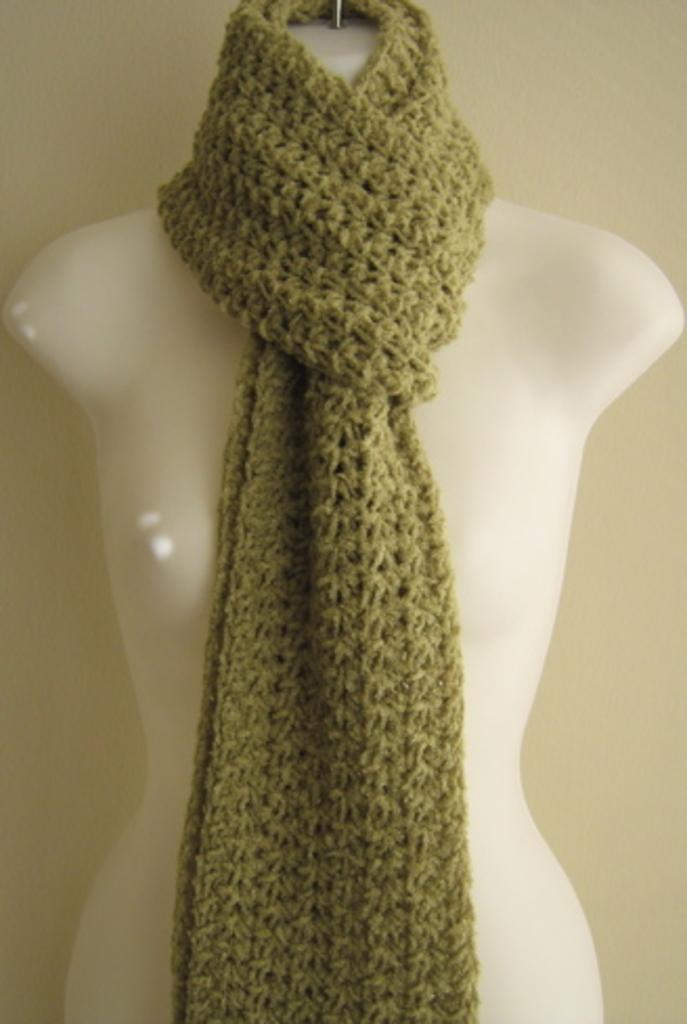What is the main subject in the image? There is a mannequin in the image. What is the mannequin wearing around its neck? The mannequin is wearing a neck wear. What can be seen behind the mannequin? There is a wall visible behind the mannequin. Can you see a glove on the mannequin's hand in the image? There is no glove visible on the mannequin's hand in the image. 